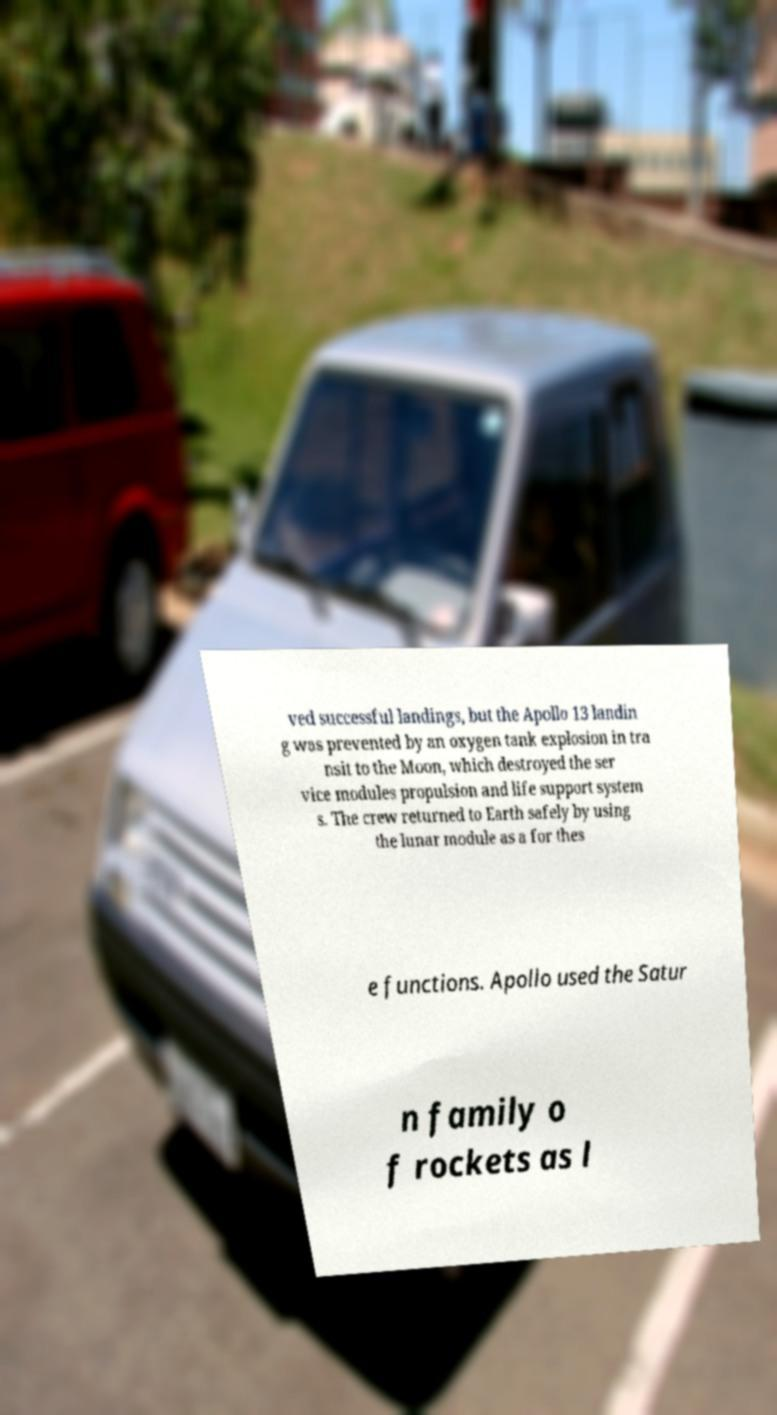What messages or text are displayed in this image? I need them in a readable, typed format. ved successful landings, but the Apollo 13 landin g was prevented by an oxygen tank explosion in tra nsit to the Moon, which destroyed the ser vice modules propulsion and life support system s. The crew returned to Earth safely by using the lunar module as a for thes e functions. Apollo used the Satur n family o f rockets as l 